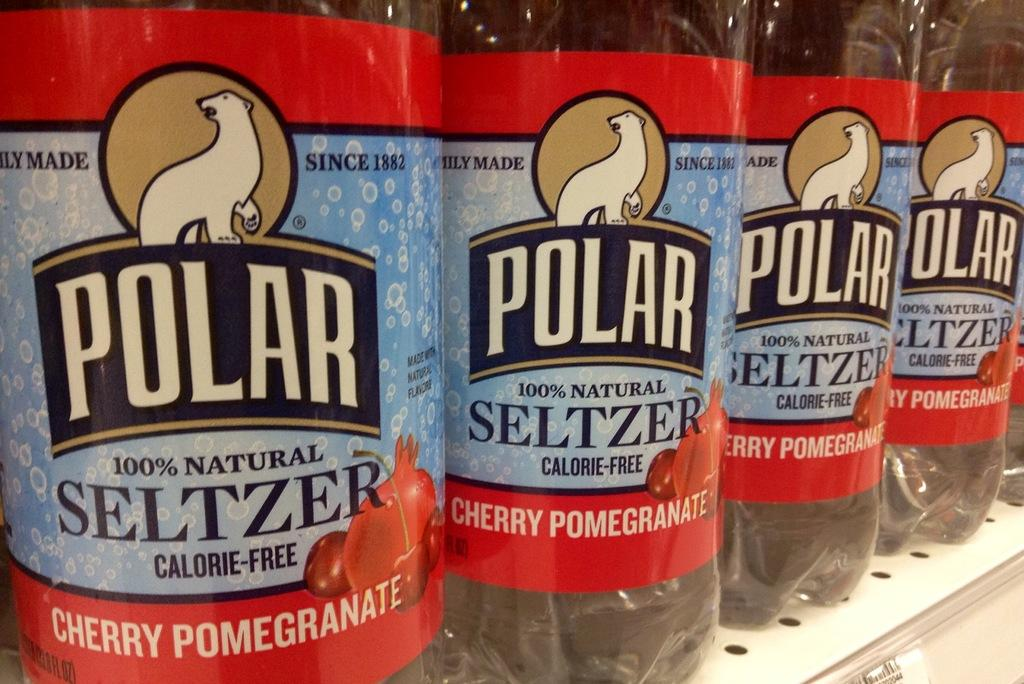<image>
Share a concise interpretation of the image provided. Bottles of cherry pomegranate Polar seltzer lined up on a shelf. 